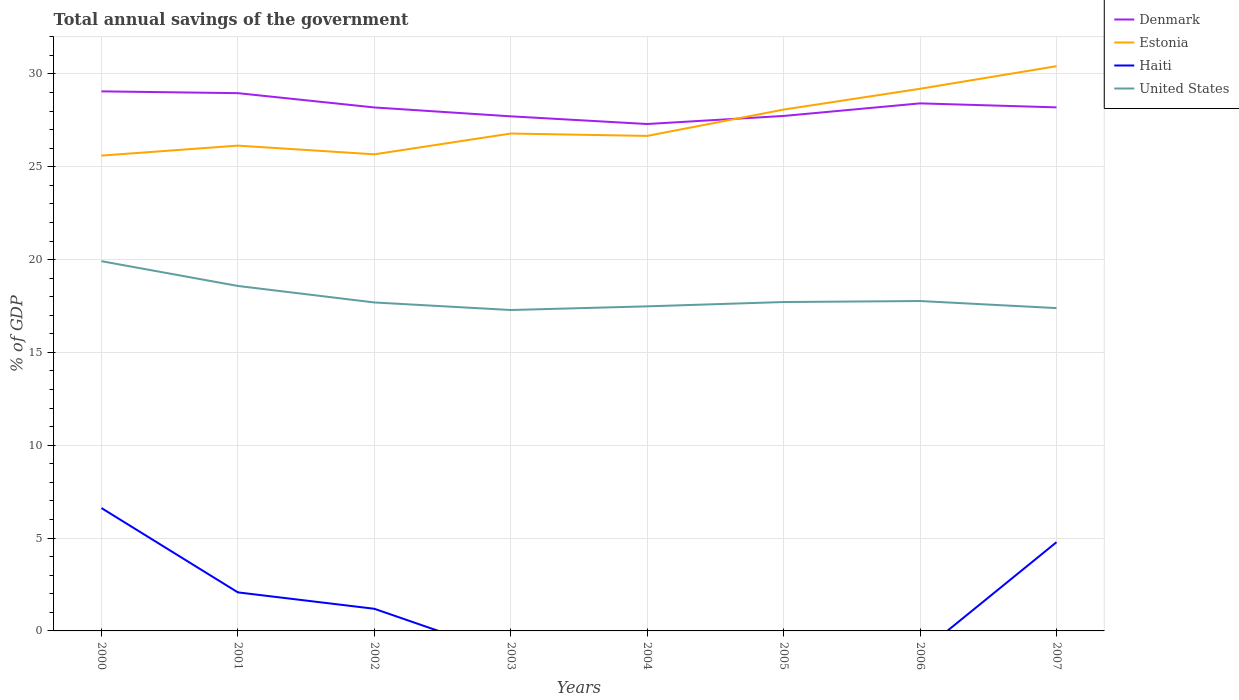How many different coloured lines are there?
Ensure brevity in your answer.  4. Across all years, what is the maximum total annual savings of the government in Estonia?
Keep it short and to the point. 25.6. What is the total total annual savings of the government in Denmark in the graph?
Make the answer very short. 0.1. What is the difference between the highest and the second highest total annual savings of the government in Denmark?
Ensure brevity in your answer.  1.76. What is the difference between the highest and the lowest total annual savings of the government in Haiti?
Provide a short and direct response. 3. How many years are there in the graph?
Your answer should be very brief. 8. What is the difference between two consecutive major ticks on the Y-axis?
Offer a very short reply. 5. Are the values on the major ticks of Y-axis written in scientific E-notation?
Offer a very short reply. No. Where does the legend appear in the graph?
Offer a very short reply. Top right. How many legend labels are there?
Ensure brevity in your answer.  4. What is the title of the graph?
Provide a succinct answer. Total annual savings of the government. Does "Suriname" appear as one of the legend labels in the graph?
Ensure brevity in your answer.  No. What is the label or title of the Y-axis?
Your response must be concise. % of GDP. What is the % of GDP of Denmark in 2000?
Offer a terse response. 29.06. What is the % of GDP of Estonia in 2000?
Keep it short and to the point. 25.6. What is the % of GDP in Haiti in 2000?
Offer a very short reply. 6.62. What is the % of GDP in United States in 2000?
Your response must be concise. 19.92. What is the % of GDP of Denmark in 2001?
Provide a short and direct response. 28.97. What is the % of GDP in Estonia in 2001?
Your answer should be very brief. 26.14. What is the % of GDP of Haiti in 2001?
Ensure brevity in your answer.  2.08. What is the % of GDP of United States in 2001?
Ensure brevity in your answer.  18.58. What is the % of GDP of Denmark in 2002?
Keep it short and to the point. 28.2. What is the % of GDP in Estonia in 2002?
Offer a terse response. 25.67. What is the % of GDP of Haiti in 2002?
Your response must be concise. 1.19. What is the % of GDP in United States in 2002?
Keep it short and to the point. 17.69. What is the % of GDP of Denmark in 2003?
Make the answer very short. 27.72. What is the % of GDP of Estonia in 2003?
Ensure brevity in your answer.  26.79. What is the % of GDP in United States in 2003?
Give a very brief answer. 17.28. What is the % of GDP in Denmark in 2004?
Offer a very short reply. 27.3. What is the % of GDP of Estonia in 2004?
Provide a succinct answer. 26.66. What is the % of GDP of Haiti in 2004?
Give a very brief answer. 0. What is the % of GDP of United States in 2004?
Offer a terse response. 17.48. What is the % of GDP of Denmark in 2005?
Make the answer very short. 27.74. What is the % of GDP of Estonia in 2005?
Your response must be concise. 28.08. What is the % of GDP of United States in 2005?
Provide a short and direct response. 17.72. What is the % of GDP in Denmark in 2006?
Your answer should be very brief. 28.42. What is the % of GDP of Estonia in 2006?
Offer a terse response. 29.2. What is the % of GDP in Haiti in 2006?
Provide a succinct answer. 0. What is the % of GDP of United States in 2006?
Your response must be concise. 17.77. What is the % of GDP of Denmark in 2007?
Provide a short and direct response. 28.2. What is the % of GDP in Estonia in 2007?
Offer a terse response. 30.42. What is the % of GDP of Haiti in 2007?
Provide a short and direct response. 4.78. What is the % of GDP of United States in 2007?
Ensure brevity in your answer.  17.39. Across all years, what is the maximum % of GDP in Denmark?
Your response must be concise. 29.06. Across all years, what is the maximum % of GDP in Estonia?
Offer a terse response. 30.42. Across all years, what is the maximum % of GDP of Haiti?
Provide a succinct answer. 6.62. Across all years, what is the maximum % of GDP in United States?
Keep it short and to the point. 19.92. Across all years, what is the minimum % of GDP of Denmark?
Offer a terse response. 27.3. Across all years, what is the minimum % of GDP in Estonia?
Ensure brevity in your answer.  25.6. Across all years, what is the minimum % of GDP of Haiti?
Provide a short and direct response. 0. Across all years, what is the minimum % of GDP in United States?
Make the answer very short. 17.28. What is the total % of GDP in Denmark in the graph?
Ensure brevity in your answer.  225.6. What is the total % of GDP in Estonia in the graph?
Provide a succinct answer. 218.57. What is the total % of GDP in Haiti in the graph?
Your response must be concise. 14.67. What is the total % of GDP in United States in the graph?
Offer a very short reply. 143.83. What is the difference between the % of GDP in Denmark in 2000 and that in 2001?
Give a very brief answer. 0.1. What is the difference between the % of GDP of Estonia in 2000 and that in 2001?
Your answer should be very brief. -0.54. What is the difference between the % of GDP in Haiti in 2000 and that in 2001?
Give a very brief answer. 4.54. What is the difference between the % of GDP of United States in 2000 and that in 2001?
Provide a short and direct response. 1.33. What is the difference between the % of GDP of Denmark in 2000 and that in 2002?
Keep it short and to the point. 0.87. What is the difference between the % of GDP in Estonia in 2000 and that in 2002?
Make the answer very short. -0.07. What is the difference between the % of GDP of Haiti in 2000 and that in 2002?
Provide a short and direct response. 5.42. What is the difference between the % of GDP in United States in 2000 and that in 2002?
Ensure brevity in your answer.  2.22. What is the difference between the % of GDP in Denmark in 2000 and that in 2003?
Your answer should be compact. 1.35. What is the difference between the % of GDP of Estonia in 2000 and that in 2003?
Provide a short and direct response. -1.19. What is the difference between the % of GDP of United States in 2000 and that in 2003?
Offer a very short reply. 2.63. What is the difference between the % of GDP of Denmark in 2000 and that in 2004?
Your response must be concise. 1.76. What is the difference between the % of GDP of Estonia in 2000 and that in 2004?
Your answer should be very brief. -1.06. What is the difference between the % of GDP of United States in 2000 and that in 2004?
Your answer should be very brief. 2.43. What is the difference between the % of GDP in Denmark in 2000 and that in 2005?
Your answer should be very brief. 1.32. What is the difference between the % of GDP of Estonia in 2000 and that in 2005?
Your answer should be very brief. -2.48. What is the difference between the % of GDP of United States in 2000 and that in 2005?
Ensure brevity in your answer.  2.2. What is the difference between the % of GDP in Denmark in 2000 and that in 2006?
Keep it short and to the point. 0.65. What is the difference between the % of GDP in Estonia in 2000 and that in 2006?
Make the answer very short. -3.6. What is the difference between the % of GDP of United States in 2000 and that in 2006?
Your answer should be very brief. 2.15. What is the difference between the % of GDP of Denmark in 2000 and that in 2007?
Provide a succinct answer. 0.86. What is the difference between the % of GDP of Estonia in 2000 and that in 2007?
Offer a very short reply. -4.82. What is the difference between the % of GDP of Haiti in 2000 and that in 2007?
Provide a succinct answer. 1.84. What is the difference between the % of GDP of United States in 2000 and that in 2007?
Your answer should be very brief. 2.53. What is the difference between the % of GDP of Denmark in 2001 and that in 2002?
Ensure brevity in your answer.  0.77. What is the difference between the % of GDP of Estonia in 2001 and that in 2002?
Keep it short and to the point. 0.47. What is the difference between the % of GDP in Haiti in 2001 and that in 2002?
Give a very brief answer. 0.88. What is the difference between the % of GDP of United States in 2001 and that in 2002?
Give a very brief answer. 0.89. What is the difference between the % of GDP in Denmark in 2001 and that in 2003?
Give a very brief answer. 1.25. What is the difference between the % of GDP in Estonia in 2001 and that in 2003?
Keep it short and to the point. -0.65. What is the difference between the % of GDP in United States in 2001 and that in 2003?
Give a very brief answer. 1.3. What is the difference between the % of GDP in Denmark in 2001 and that in 2004?
Offer a very short reply. 1.66. What is the difference between the % of GDP of Estonia in 2001 and that in 2004?
Ensure brevity in your answer.  -0.52. What is the difference between the % of GDP in United States in 2001 and that in 2004?
Offer a terse response. 1.1. What is the difference between the % of GDP of Denmark in 2001 and that in 2005?
Your response must be concise. 1.23. What is the difference between the % of GDP in Estonia in 2001 and that in 2005?
Your answer should be very brief. -1.94. What is the difference between the % of GDP of United States in 2001 and that in 2005?
Make the answer very short. 0.87. What is the difference between the % of GDP in Denmark in 2001 and that in 2006?
Offer a very short reply. 0.55. What is the difference between the % of GDP of Estonia in 2001 and that in 2006?
Give a very brief answer. -3.06. What is the difference between the % of GDP of United States in 2001 and that in 2006?
Offer a terse response. 0.81. What is the difference between the % of GDP of Denmark in 2001 and that in 2007?
Provide a succinct answer. 0.77. What is the difference between the % of GDP of Estonia in 2001 and that in 2007?
Ensure brevity in your answer.  -4.28. What is the difference between the % of GDP in Haiti in 2001 and that in 2007?
Provide a short and direct response. -2.7. What is the difference between the % of GDP in United States in 2001 and that in 2007?
Make the answer very short. 1.19. What is the difference between the % of GDP of Denmark in 2002 and that in 2003?
Provide a succinct answer. 0.48. What is the difference between the % of GDP of Estonia in 2002 and that in 2003?
Your answer should be compact. -1.12. What is the difference between the % of GDP in United States in 2002 and that in 2003?
Your response must be concise. 0.41. What is the difference between the % of GDP in Denmark in 2002 and that in 2004?
Provide a succinct answer. 0.89. What is the difference between the % of GDP of Estonia in 2002 and that in 2004?
Offer a very short reply. -0.99. What is the difference between the % of GDP in United States in 2002 and that in 2004?
Ensure brevity in your answer.  0.21. What is the difference between the % of GDP of Denmark in 2002 and that in 2005?
Provide a short and direct response. 0.46. What is the difference between the % of GDP in Estonia in 2002 and that in 2005?
Make the answer very short. -2.41. What is the difference between the % of GDP of United States in 2002 and that in 2005?
Your response must be concise. -0.02. What is the difference between the % of GDP in Denmark in 2002 and that in 2006?
Give a very brief answer. -0.22. What is the difference between the % of GDP in Estonia in 2002 and that in 2006?
Provide a short and direct response. -3.53. What is the difference between the % of GDP of United States in 2002 and that in 2006?
Your answer should be very brief. -0.08. What is the difference between the % of GDP of Denmark in 2002 and that in 2007?
Your answer should be very brief. -0.01. What is the difference between the % of GDP in Estonia in 2002 and that in 2007?
Make the answer very short. -4.75. What is the difference between the % of GDP in Haiti in 2002 and that in 2007?
Make the answer very short. -3.59. What is the difference between the % of GDP of United States in 2002 and that in 2007?
Make the answer very short. 0.3. What is the difference between the % of GDP in Denmark in 2003 and that in 2004?
Provide a succinct answer. 0.41. What is the difference between the % of GDP of Estonia in 2003 and that in 2004?
Provide a succinct answer. 0.13. What is the difference between the % of GDP of United States in 2003 and that in 2004?
Provide a short and direct response. -0.2. What is the difference between the % of GDP in Denmark in 2003 and that in 2005?
Offer a very short reply. -0.02. What is the difference between the % of GDP of Estonia in 2003 and that in 2005?
Ensure brevity in your answer.  -1.29. What is the difference between the % of GDP of United States in 2003 and that in 2005?
Offer a terse response. -0.43. What is the difference between the % of GDP of Denmark in 2003 and that in 2006?
Your answer should be very brief. -0.7. What is the difference between the % of GDP of Estonia in 2003 and that in 2006?
Provide a succinct answer. -2.41. What is the difference between the % of GDP of United States in 2003 and that in 2006?
Your answer should be very brief. -0.48. What is the difference between the % of GDP of Denmark in 2003 and that in 2007?
Provide a succinct answer. -0.48. What is the difference between the % of GDP of Estonia in 2003 and that in 2007?
Provide a succinct answer. -3.63. What is the difference between the % of GDP of United States in 2003 and that in 2007?
Keep it short and to the point. -0.1. What is the difference between the % of GDP of Denmark in 2004 and that in 2005?
Offer a terse response. -0.44. What is the difference between the % of GDP of Estonia in 2004 and that in 2005?
Your answer should be compact. -1.42. What is the difference between the % of GDP in United States in 2004 and that in 2005?
Provide a succinct answer. -0.23. What is the difference between the % of GDP of Denmark in 2004 and that in 2006?
Your answer should be very brief. -1.11. What is the difference between the % of GDP in Estonia in 2004 and that in 2006?
Give a very brief answer. -2.54. What is the difference between the % of GDP of United States in 2004 and that in 2006?
Your response must be concise. -0.29. What is the difference between the % of GDP of Denmark in 2004 and that in 2007?
Your answer should be compact. -0.9. What is the difference between the % of GDP in Estonia in 2004 and that in 2007?
Offer a very short reply. -3.75. What is the difference between the % of GDP of United States in 2004 and that in 2007?
Offer a very short reply. 0.09. What is the difference between the % of GDP in Denmark in 2005 and that in 2006?
Provide a succinct answer. -0.68. What is the difference between the % of GDP in Estonia in 2005 and that in 2006?
Ensure brevity in your answer.  -1.12. What is the difference between the % of GDP of United States in 2005 and that in 2006?
Your answer should be very brief. -0.05. What is the difference between the % of GDP in Denmark in 2005 and that in 2007?
Make the answer very short. -0.46. What is the difference between the % of GDP in Estonia in 2005 and that in 2007?
Offer a very short reply. -2.34. What is the difference between the % of GDP of United States in 2005 and that in 2007?
Your answer should be very brief. 0.33. What is the difference between the % of GDP of Denmark in 2006 and that in 2007?
Provide a succinct answer. 0.22. What is the difference between the % of GDP in Estonia in 2006 and that in 2007?
Offer a very short reply. -1.22. What is the difference between the % of GDP of United States in 2006 and that in 2007?
Provide a short and direct response. 0.38. What is the difference between the % of GDP in Denmark in 2000 and the % of GDP in Estonia in 2001?
Keep it short and to the point. 2.92. What is the difference between the % of GDP of Denmark in 2000 and the % of GDP of Haiti in 2001?
Your answer should be compact. 26.99. What is the difference between the % of GDP of Denmark in 2000 and the % of GDP of United States in 2001?
Your answer should be compact. 10.48. What is the difference between the % of GDP in Estonia in 2000 and the % of GDP in Haiti in 2001?
Ensure brevity in your answer.  23.53. What is the difference between the % of GDP of Estonia in 2000 and the % of GDP of United States in 2001?
Your answer should be compact. 7.02. What is the difference between the % of GDP of Haiti in 2000 and the % of GDP of United States in 2001?
Offer a very short reply. -11.96. What is the difference between the % of GDP of Denmark in 2000 and the % of GDP of Estonia in 2002?
Ensure brevity in your answer.  3.39. What is the difference between the % of GDP in Denmark in 2000 and the % of GDP in Haiti in 2002?
Provide a short and direct response. 27.87. What is the difference between the % of GDP in Denmark in 2000 and the % of GDP in United States in 2002?
Make the answer very short. 11.37. What is the difference between the % of GDP in Estonia in 2000 and the % of GDP in Haiti in 2002?
Your answer should be very brief. 24.41. What is the difference between the % of GDP of Estonia in 2000 and the % of GDP of United States in 2002?
Ensure brevity in your answer.  7.91. What is the difference between the % of GDP of Haiti in 2000 and the % of GDP of United States in 2002?
Your answer should be compact. -11.07. What is the difference between the % of GDP of Denmark in 2000 and the % of GDP of Estonia in 2003?
Your answer should be compact. 2.27. What is the difference between the % of GDP in Denmark in 2000 and the % of GDP in United States in 2003?
Ensure brevity in your answer.  11.78. What is the difference between the % of GDP in Estonia in 2000 and the % of GDP in United States in 2003?
Ensure brevity in your answer.  8.32. What is the difference between the % of GDP in Haiti in 2000 and the % of GDP in United States in 2003?
Offer a terse response. -10.67. What is the difference between the % of GDP in Denmark in 2000 and the % of GDP in Estonia in 2004?
Offer a very short reply. 2.4. What is the difference between the % of GDP of Denmark in 2000 and the % of GDP of United States in 2004?
Your answer should be compact. 11.58. What is the difference between the % of GDP in Estonia in 2000 and the % of GDP in United States in 2004?
Your response must be concise. 8.12. What is the difference between the % of GDP in Haiti in 2000 and the % of GDP in United States in 2004?
Provide a succinct answer. -10.86. What is the difference between the % of GDP of Denmark in 2000 and the % of GDP of Estonia in 2005?
Your answer should be compact. 0.98. What is the difference between the % of GDP of Denmark in 2000 and the % of GDP of United States in 2005?
Keep it short and to the point. 11.35. What is the difference between the % of GDP of Estonia in 2000 and the % of GDP of United States in 2005?
Your answer should be very brief. 7.89. What is the difference between the % of GDP of Haiti in 2000 and the % of GDP of United States in 2005?
Give a very brief answer. -11.1. What is the difference between the % of GDP of Denmark in 2000 and the % of GDP of Estonia in 2006?
Your answer should be compact. -0.14. What is the difference between the % of GDP in Denmark in 2000 and the % of GDP in United States in 2006?
Provide a short and direct response. 11.29. What is the difference between the % of GDP of Estonia in 2000 and the % of GDP of United States in 2006?
Your response must be concise. 7.83. What is the difference between the % of GDP of Haiti in 2000 and the % of GDP of United States in 2006?
Your answer should be compact. -11.15. What is the difference between the % of GDP of Denmark in 2000 and the % of GDP of Estonia in 2007?
Your answer should be very brief. -1.36. What is the difference between the % of GDP in Denmark in 2000 and the % of GDP in Haiti in 2007?
Keep it short and to the point. 24.28. What is the difference between the % of GDP in Denmark in 2000 and the % of GDP in United States in 2007?
Keep it short and to the point. 11.67. What is the difference between the % of GDP of Estonia in 2000 and the % of GDP of Haiti in 2007?
Your answer should be compact. 20.82. What is the difference between the % of GDP in Estonia in 2000 and the % of GDP in United States in 2007?
Offer a terse response. 8.21. What is the difference between the % of GDP of Haiti in 2000 and the % of GDP of United States in 2007?
Provide a short and direct response. -10.77. What is the difference between the % of GDP of Denmark in 2001 and the % of GDP of Estonia in 2002?
Keep it short and to the point. 3.29. What is the difference between the % of GDP of Denmark in 2001 and the % of GDP of Haiti in 2002?
Provide a succinct answer. 27.77. What is the difference between the % of GDP of Denmark in 2001 and the % of GDP of United States in 2002?
Provide a short and direct response. 11.27. What is the difference between the % of GDP in Estonia in 2001 and the % of GDP in Haiti in 2002?
Offer a terse response. 24.95. What is the difference between the % of GDP in Estonia in 2001 and the % of GDP in United States in 2002?
Give a very brief answer. 8.45. What is the difference between the % of GDP in Haiti in 2001 and the % of GDP in United States in 2002?
Ensure brevity in your answer.  -15.62. What is the difference between the % of GDP in Denmark in 2001 and the % of GDP in Estonia in 2003?
Provide a short and direct response. 2.17. What is the difference between the % of GDP in Denmark in 2001 and the % of GDP in United States in 2003?
Provide a succinct answer. 11.68. What is the difference between the % of GDP in Estonia in 2001 and the % of GDP in United States in 2003?
Provide a short and direct response. 8.86. What is the difference between the % of GDP in Haiti in 2001 and the % of GDP in United States in 2003?
Provide a short and direct response. -15.21. What is the difference between the % of GDP of Denmark in 2001 and the % of GDP of Estonia in 2004?
Ensure brevity in your answer.  2.3. What is the difference between the % of GDP in Denmark in 2001 and the % of GDP in United States in 2004?
Ensure brevity in your answer.  11.48. What is the difference between the % of GDP in Estonia in 2001 and the % of GDP in United States in 2004?
Your response must be concise. 8.66. What is the difference between the % of GDP in Haiti in 2001 and the % of GDP in United States in 2004?
Provide a succinct answer. -15.41. What is the difference between the % of GDP of Denmark in 2001 and the % of GDP of Estonia in 2005?
Your answer should be very brief. 0.89. What is the difference between the % of GDP of Denmark in 2001 and the % of GDP of United States in 2005?
Offer a very short reply. 11.25. What is the difference between the % of GDP of Estonia in 2001 and the % of GDP of United States in 2005?
Your answer should be compact. 8.42. What is the difference between the % of GDP of Haiti in 2001 and the % of GDP of United States in 2005?
Provide a short and direct response. -15.64. What is the difference between the % of GDP of Denmark in 2001 and the % of GDP of Estonia in 2006?
Your answer should be very brief. -0.24. What is the difference between the % of GDP of Denmark in 2001 and the % of GDP of United States in 2006?
Your answer should be very brief. 11.2. What is the difference between the % of GDP of Estonia in 2001 and the % of GDP of United States in 2006?
Your answer should be very brief. 8.37. What is the difference between the % of GDP of Haiti in 2001 and the % of GDP of United States in 2006?
Offer a very short reply. -15.69. What is the difference between the % of GDP of Denmark in 2001 and the % of GDP of Estonia in 2007?
Your response must be concise. -1.45. What is the difference between the % of GDP of Denmark in 2001 and the % of GDP of Haiti in 2007?
Make the answer very short. 24.19. What is the difference between the % of GDP in Denmark in 2001 and the % of GDP in United States in 2007?
Ensure brevity in your answer.  11.58. What is the difference between the % of GDP of Estonia in 2001 and the % of GDP of Haiti in 2007?
Ensure brevity in your answer.  21.36. What is the difference between the % of GDP in Estonia in 2001 and the % of GDP in United States in 2007?
Make the answer very short. 8.75. What is the difference between the % of GDP in Haiti in 2001 and the % of GDP in United States in 2007?
Your answer should be very brief. -15.31. What is the difference between the % of GDP in Denmark in 2002 and the % of GDP in Estonia in 2003?
Your answer should be compact. 1.4. What is the difference between the % of GDP in Denmark in 2002 and the % of GDP in United States in 2003?
Offer a very short reply. 10.91. What is the difference between the % of GDP in Estonia in 2002 and the % of GDP in United States in 2003?
Your answer should be compact. 8.39. What is the difference between the % of GDP in Haiti in 2002 and the % of GDP in United States in 2003?
Provide a succinct answer. -16.09. What is the difference between the % of GDP of Denmark in 2002 and the % of GDP of Estonia in 2004?
Provide a short and direct response. 1.53. What is the difference between the % of GDP of Denmark in 2002 and the % of GDP of United States in 2004?
Offer a terse response. 10.71. What is the difference between the % of GDP in Estonia in 2002 and the % of GDP in United States in 2004?
Provide a short and direct response. 8.19. What is the difference between the % of GDP in Haiti in 2002 and the % of GDP in United States in 2004?
Keep it short and to the point. -16.29. What is the difference between the % of GDP in Denmark in 2002 and the % of GDP in Estonia in 2005?
Ensure brevity in your answer.  0.12. What is the difference between the % of GDP in Denmark in 2002 and the % of GDP in United States in 2005?
Ensure brevity in your answer.  10.48. What is the difference between the % of GDP in Estonia in 2002 and the % of GDP in United States in 2005?
Provide a succinct answer. 7.96. What is the difference between the % of GDP in Haiti in 2002 and the % of GDP in United States in 2005?
Offer a very short reply. -16.52. What is the difference between the % of GDP in Denmark in 2002 and the % of GDP in Estonia in 2006?
Your answer should be compact. -1.01. What is the difference between the % of GDP in Denmark in 2002 and the % of GDP in United States in 2006?
Offer a terse response. 10.43. What is the difference between the % of GDP of Estonia in 2002 and the % of GDP of United States in 2006?
Your answer should be compact. 7.9. What is the difference between the % of GDP of Haiti in 2002 and the % of GDP of United States in 2006?
Give a very brief answer. -16.58. What is the difference between the % of GDP in Denmark in 2002 and the % of GDP in Estonia in 2007?
Give a very brief answer. -2.22. What is the difference between the % of GDP of Denmark in 2002 and the % of GDP of Haiti in 2007?
Your answer should be very brief. 23.42. What is the difference between the % of GDP of Denmark in 2002 and the % of GDP of United States in 2007?
Your answer should be compact. 10.81. What is the difference between the % of GDP in Estonia in 2002 and the % of GDP in Haiti in 2007?
Provide a succinct answer. 20.89. What is the difference between the % of GDP of Estonia in 2002 and the % of GDP of United States in 2007?
Your answer should be very brief. 8.28. What is the difference between the % of GDP of Haiti in 2002 and the % of GDP of United States in 2007?
Your answer should be compact. -16.2. What is the difference between the % of GDP in Denmark in 2003 and the % of GDP in Estonia in 2004?
Offer a very short reply. 1.05. What is the difference between the % of GDP of Denmark in 2003 and the % of GDP of United States in 2004?
Your answer should be very brief. 10.23. What is the difference between the % of GDP in Estonia in 2003 and the % of GDP in United States in 2004?
Ensure brevity in your answer.  9.31. What is the difference between the % of GDP in Denmark in 2003 and the % of GDP in Estonia in 2005?
Keep it short and to the point. -0.36. What is the difference between the % of GDP of Denmark in 2003 and the % of GDP of United States in 2005?
Offer a terse response. 10. What is the difference between the % of GDP in Estonia in 2003 and the % of GDP in United States in 2005?
Keep it short and to the point. 9.08. What is the difference between the % of GDP in Denmark in 2003 and the % of GDP in Estonia in 2006?
Ensure brevity in your answer.  -1.49. What is the difference between the % of GDP of Denmark in 2003 and the % of GDP of United States in 2006?
Give a very brief answer. 9.95. What is the difference between the % of GDP of Estonia in 2003 and the % of GDP of United States in 2006?
Ensure brevity in your answer.  9.02. What is the difference between the % of GDP of Denmark in 2003 and the % of GDP of Estonia in 2007?
Your response must be concise. -2.7. What is the difference between the % of GDP in Denmark in 2003 and the % of GDP in Haiti in 2007?
Provide a short and direct response. 22.94. What is the difference between the % of GDP in Denmark in 2003 and the % of GDP in United States in 2007?
Your answer should be compact. 10.33. What is the difference between the % of GDP in Estonia in 2003 and the % of GDP in Haiti in 2007?
Keep it short and to the point. 22.01. What is the difference between the % of GDP in Estonia in 2003 and the % of GDP in United States in 2007?
Keep it short and to the point. 9.4. What is the difference between the % of GDP in Denmark in 2004 and the % of GDP in Estonia in 2005?
Provide a succinct answer. -0.78. What is the difference between the % of GDP in Denmark in 2004 and the % of GDP in United States in 2005?
Give a very brief answer. 9.59. What is the difference between the % of GDP of Estonia in 2004 and the % of GDP of United States in 2005?
Provide a succinct answer. 8.95. What is the difference between the % of GDP of Denmark in 2004 and the % of GDP of Estonia in 2006?
Keep it short and to the point. -1.9. What is the difference between the % of GDP of Denmark in 2004 and the % of GDP of United States in 2006?
Keep it short and to the point. 9.53. What is the difference between the % of GDP in Estonia in 2004 and the % of GDP in United States in 2006?
Make the answer very short. 8.89. What is the difference between the % of GDP in Denmark in 2004 and the % of GDP in Estonia in 2007?
Keep it short and to the point. -3.12. What is the difference between the % of GDP in Denmark in 2004 and the % of GDP in Haiti in 2007?
Offer a very short reply. 22.52. What is the difference between the % of GDP in Denmark in 2004 and the % of GDP in United States in 2007?
Give a very brief answer. 9.91. What is the difference between the % of GDP in Estonia in 2004 and the % of GDP in Haiti in 2007?
Offer a very short reply. 21.88. What is the difference between the % of GDP of Estonia in 2004 and the % of GDP of United States in 2007?
Your answer should be very brief. 9.27. What is the difference between the % of GDP of Denmark in 2005 and the % of GDP of Estonia in 2006?
Ensure brevity in your answer.  -1.46. What is the difference between the % of GDP of Denmark in 2005 and the % of GDP of United States in 2006?
Your response must be concise. 9.97. What is the difference between the % of GDP of Estonia in 2005 and the % of GDP of United States in 2006?
Provide a short and direct response. 10.31. What is the difference between the % of GDP of Denmark in 2005 and the % of GDP of Estonia in 2007?
Ensure brevity in your answer.  -2.68. What is the difference between the % of GDP of Denmark in 2005 and the % of GDP of Haiti in 2007?
Your response must be concise. 22.96. What is the difference between the % of GDP in Denmark in 2005 and the % of GDP in United States in 2007?
Give a very brief answer. 10.35. What is the difference between the % of GDP in Estonia in 2005 and the % of GDP in Haiti in 2007?
Offer a very short reply. 23.3. What is the difference between the % of GDP in Estonia in 2005 and the % of GDP in United States in 2007?
Provide a succinct answer. 10.69. What is the difference between the % of GDP in Denmark in 2006 and the % of GDP in Estonia in 2007?
Provide a short and direct response. -2. What is the difference between the % of GDP of Denmark in 2006 and the % of GDP of Haiti in 2007?
Keep it short and to the point. 23.64. What is the difference between the % of GDP in Denmark in 2006 and the % of GDP in United States in 2007?
Make the answer very short. 11.03. What is the difference between the % of GDP in Estonia in 2006 and the % of GDP in Haiti in 2007?
Make the answer very short. 24.42. What is the difference between the % of GDP of Estonia in 2006 and the % of GDP of United States in 2007?
Ensure brevity in your answer.  11.81. What is the average % of GDP in Denmark per year?
Offer a terse response. 28.2. What is the average % of GDP in Estonia per year?
Provide a short and direct response. 27.32. What is the average % of GDP in Haiti per year?
Your answer should be very brief. 1.83. What is the average % of GDP in United States per year?
Provide a short and direct response. 17.98. In the year 2000, what is the difference between the % of GDP of Denmark and % of GDP of Estonia?
Give a very brief answer. 3.46. In the year 2000, what is the difference between the % of GDP of Denmark and % of GDP of Haiti?
Provide a succinct answer. 22.44. In the year 2000, what is the difference between the % of GDP in Denmark and % of GDP in United States?
Offer a very short reply. 9.15. In the year 2000, what is the difference between the % of GDP of Estonia and % of GDP of Haiti?
Your response must be concise. 18.98. In the year 2000, what is the difference between the % of GDP in Estonia and % of GDP in United States?
Offer a very short reply. 5.69. In the year 2000, what is the difference between the % of GDP in Haiti and % of GDP in United States?
Provide a succinct answer. -13.3. In the year 2001, what is the difference between the % of GDP of Denmark and % of GDP of Estonia?
Ensure brevity in your answer.  2.83. In the year 2001, what is the difference between the % of GDP of Denmark and % of GDP of Haiti?
Your answer should be compact. 26.89. In the year 2001, what is the difference between the % of GDP of Denmark and % of GDP of United States?
Your answer should be compact. 10.39. In the year 2001, what is the difference between the % of GDP in Estonia and % of GDP in Haiti?
Your answer should be compact. 24.06. In the year 2001, what is the difference between the % of GDP in Estonia and % of GDP in United States?
Keep it short and to the point. 7.56. In the year 2001, what is the difference between the % of GDP of Haiti and % of GDP of United States?
Provide a succinct answer. -16.5. In the year 2002, what is the difference between the % of GDP of Denmark and % of GDP of Estonia?
Your answer should be very brief. 2.52. In the year 2002, what is the difference between the % of GDP of Denmark and % of GDP of Haiti?
Your answer should be very brief. 27. In the year 2002, what is the difference between the % of GDP in Denmark and % of GDP in United States?
Keep it short and to the point. 10.5. In the year 2002, what is the difference between the % of GDP of Estonia and % of GDP of Haiti?
Make the answer very short. 24.48. In the year 2002, what is the difference between the % of GDP of Estonia and % of GDP of United States?
Give a very brief answer. 7.98. In the year 2002, what is the difference between the % of GDP in Haiti and % of GDP in United States?
Ensure brevity in your answer.  -16.5. In the year 2003, what is the difference between the % of GDP in Denmark and % of GDP in Estonia?
Provide a short and direct response. 0.93. In the year 2003, what is the difference between the % of GDP in Denmark and % of GDP in United States?
Make the answer very short. 10.43. In the year 2003, what is the difference between the % of GDP of Estonia and % of GDP of United States?
Give a very brief answer. 9.51. In the year 2004, what is the difference between the % of GDP in Denmark and % of GDP in Estonia?
Your answer should be compact. 0.64. In the year 2004, what is the difference between the % of GDP of Denmark and % of GDP of United States?
Offer a terse response. 9.82. In the year 2004, what is the difference between the % of GDP of Estonia and % of GDP of United States?
Offer a very short reply. 9.18. In the year 2005, what is the difference between the % of GDP in Denmark and % of GDP in Estonia?
Provide a succinct answer. -0.34. In the year 2005, what is the difference between the % of GDP in Denmark and % of GDP in United States?
Ensure brevity in your answer.  10.02. In the year 2005, what is the difference between the % of GDP in Estonia and % of GDP in United States?
Ensure brevity in your answer.  10.36. In the year 2006, what is the difference between the % of GDP in Denmark and % of GDP in Estonia?
Give a very brief answer. -0.79. In the year 2006, what is the difference between the % of GDP of Denmark and % of GDP of United States?
Keep it short and to the point. 10.65. In the year 2006, what is the difference between the % of GDP in Estonia and % of GDP in United States?
Offer a very short reply. 11.43. In the year 2007, what is the difference between the % of GDP in Denmark and % of GDP in Estonia?
Your answer should be compact. -2.22. In the year 2007, what is the difference between the % of GDP in Denmark and % of GDP in Haiti?
Offer a terse response. 23.42. In the year 2007, what is the difference between the % of GDP in Denmark and % of GDP in United States?
Your answer should be very brief. 10.81. In the year 2007, what is the difference between the % of GDP in Estonia and % of GDP in Haiti?
Offer a very short reply. 25.64. In the year 2007, what is the difference between the % of GDP of Estonia and % of GDP of United States?
Offer a terse response. 13.03. In the year 2007, what is the difference between the % of GDP of Haiti and % of GDP of United States?
Give a very brief answer. -12.61. What is the ratio of the % of GDP of Estonia in 2000 to that in 2001?
Your answer should be compact. 0.98. What is the ratio of the % of GDP of Haiti in 2000 to that in 2001?
Your response must be concise. 3.19. What is the ratio of the % of GDP of United States in 2000 to that in 2001?
Offer a terse response. 1.07. What is the ratio of the % of GDP in Denmark in 2000 to that in 2002?
Provide a short and direct response. 1.03. What is the ratio of the % of GDP of Haiti in 2000 to that in 2002?
Ensure brevity in your answer.  5.55. What is the ratio of the % of GDP of United States in 2000 to that in 2002?
Offer a terse response. 1.13. What is the ratio of the % of GDP of Denmark in 2000 to that in 2003?
Keep it short and to the point. 1.05. What is the ratio of the % of GDP of Estonia in 2000 to that in 2003?
Your answer should be compact. 0.96. What is the ratio of the % of GDP of United States in 2000 to that in 2003?
Provide a succinct answer. 1.15. What is the ratio of the % of GDP in Denmark in 2000 to that in 2004?
Your answer should be compact. 1.06. What is the ratio of the % of GDP of Estonia in 2000 to that in 2004?
Ensure brevity in your answer.  0.96. What is the ratio of the % of GDP in United States in 2000 to that in 2004?
Your response must be concise. 1.14. What is the ratio of the % of GDP in Denmark in 2000 to that in 2005?
Offer a terse response. 1.05. What is the ratio of the % of GDP of Estonia in 2000 to that in 2005?
Give a very brief answer. 0.91. What is the ratio of the % of GDP in United States in 2000 to that in 2005?
Your response must be concise. 1.12. What is the ratio of the % of GDP of Denmark in 2000 to that in 2006?
Provide a succinct answer. 1.02. What is the ratio of the % of GDP in Estonia in 2000 to that in 2006?
Offer a terse response. 0.88. What is the ratio of the % of GDP of United States in 2000 to that in 2006?
Provide a short and direct response. 1.12. What is the ratio of the % of GDP in Denmark in 2000 to that in 2007?
Make the answer very short. 1.03. What is the ratio of the % of GDP in Estonia in 2000 to that in 2007?
Your answer should be very brief. 0.84. What is the ratio of the % of GDP in Haiti in 2000 to that in 2007?
Offer a terse response. 1.38. What is the ratio of the % of GDP of United States in 2000 to that in 2007?
Ensure brevity in your answer.  1.15. What is the ratio of the % of GDP in Denmark in 2001 to that in 2002?
Ensure brevity in your answer.  1.03. What is the ratio of the % of GDP in Estonia in 2001 to that in 2002?
Keep it short and to the point. 1.02. What is the ratio of the % of GDP in Haiti in 2001 to that in 2002?
Offer a very short reply. 1.74. What is the ratio of the % of GDP in United States in 2001 to that in 2002?
Your answer should be very brief. 1.05. What is the ratio of the % of GDP in Denmark in 2001 to that in 2003?
Your answer should be very brief. 1.05. What is the ratio of the % of GDP of Estonia in 2001 to that in 2003?
Ensure brevity in your answer.  0.98. What is the ratio of the % of GDP of United States in 2001 to that in 2003?
Keep it short and to the point. 1.07. What is the ratio of the % of GDP in Denmark in 2001 to that in 2004?
Provide a succinct answer. 1.06. What is the ratio of the % of GDP of Estonia in 2001 to that in 2004?
Make the answer very short. 0.98. What is the ratio of the % of GDP of United States in 2001 to that in 2004?
Keep it short and to the point. 1.06. What is the ratio of the % of GDP of Denmark in 2001 to that in 2005?
Ensure brevity in your answer.  1.04. What is the ratio of the % of GDP of Estonia in 2001 to that in 2005?
Keep it short and to the point. 0.93. What is the ratio of the % of GDP of United States in 2001 to that in 2005?
Make the answer very short. 1.05. What is the ratio of the % of GDP in Denmark in 2001 to that in 2006?
Give a very brief answer. 1.02. What is the ratio of the % of GDP in Estonia in 2001 to that in 2006?
Provide a succinct answer. 0.9. What is the ratio of the % of GDP in United States in 2001 to that in 2006?
Offer a very short reply. 1.05. What is the ratio of the % of GDP in Denmark in 2001 to that in 2007?
Make the answer very short. 1.03. What is the ratio of the % of GDP in Estonia in 2001 to that in 2007?
Offer a terse response. 0.86. What is the ratio of the % of GDP in Haiti in 2001 to that in 2007?
Provide a short and direct response. 0.43. What is the ratio of the % of GDP in United States in 2001 to that in 2007?
Provide a short and direct response. 1.07. What is the ratio of the % of GDP of Denmark in 2002 to that in 2003?
Ensure brevity in your answer.  1.02. What is the ratio of the % of GDP in Estonia in 2002 to that in 2003?
Your answer should be very brief. 0.96. What is the ratio of the % of GDP in United States in 2002 to that in 2003?
Your response must be concise. 1.02. What is the ratio of the % of GDP in Denmark in 2002 to that in 2004?
Your answer should be very brief. 1.03. What is the ratio of the % of GDP of Estonia in 2002 to that in 2004?
Provide a succinct answer. 0.96. What is the ratio of the % of GDP in Denmark in 2002 to that in 2005?
Your answer should be compact. 1.02. What is the ratio of the % of GDP of Estonia in 2002 to that in 2005?
Make the answer very short. 0.91. What is the ratio of the % of GDP of Estonia in 2002 to that in 2006?
Give a very brief answer. 0.88. What is the ratio of the % of GDP of Estonia in 2002 to that in 2007?
Give a very brief answer. 0.84. What is the ratio of the % of GDP in Haiti in 2002 to that in 2007?
Offer a very short reply. 0.25. What is the ratio of the % of GDP of United States in 2002 to that in 2007?
Keep it short and to the point. 1.02. What is the ratio of the % of GDP in Denmark in 2003 to that in 2004?
Ensure brevity in your answer.  1.02. What is the ratio of the % of GDP of United States in 2003 to that in 2004?
Offer a terse response. 0.99. What is the ratio of the % of GDP in Denmark in 2003 to that in 2005?
Ensure brevity in your answer.  1. What is the ratio of the % of GDP in Estonia in 2003 to that in 2005?
Make the answer very short. 0.95. What is the ratio of the % of GDP of United States in 2003 to that in 2005?
Offer a terse response. 0.98. What is the ratio of the % of GDP of Denmark in 2003 to that in 2006?
Your answer should be compact. 0.98. What is the ratio of the % of GDP in Estonia in 2003 to that in 2006?
Offer a very short reply. 0.92. What is the ratio of the % of GDP in United States in 2003 to that in 2006?
Your answer should be compact. 0.97. What is the ratio of the % of GDP of Denmark in 2003 to that in 2007?
Offer a very short reply. 0.98. What is the ratio of the % of GDP in Estonia in 2003 to that in 2007?
Offer a terse response. 0.88. What is the ratio of the % of GDP of Denmark in 2004 to that in 2005?
Your answer should be very brief. 0.98. What is the ratio of the % of GDP of Estonia in 2004 to that in 2005?
Your response must be concise. 0.95. What is the ratio of the % of GDP in United States in 2004 to that in 2005?
Offer a terse response. 0.99. What is the ratio of the % of GDP in Denmark in 2004 to that in 2006?
Offer a terse response. 0.96. What is the ratio of the % of GDP in Estonia in 2004 to that in 2006?
Your answer should be compact. 0.91. What is the ratio of the % of GDP in United States in 2004 to that in 2006?
Provide a succinct answer. 0.98. What is the ratio of the % of GDP of Denmark in 2004 to that in 2007?
Your response must be concise. 0.97. What is the ratio of the % of GDP in Estonia in 2004 to that in 2007?
Keep it short and to the point. 0.88. What is the ratio of the % of GDP in United States in 2004 to that in 2007?
Make the answer very short. 1.01. What is the ratio of the % of GDP in Denmark in 2005 to that in 2006?
Keep it short and to the point. 0.98. What is the ratio of the % of GDP of Estonia in 2005 to that in 2006?
Your response must be concise. 0.96. What is the ratio of the % of GDP in United States in 2005 to that in 2006?
Provide a succinct answer. 1. What is the ratio of the % of GDP in Denmark in 2005 to that in 2007?
Your response must be concise. 0.98. What is the ratio of the % of GDP of Estonia in 2005 to that in 2007?
Offer a terse response. 0.92. What is the ratio of the % of GDP of United States in 2005 to that in 2007?
Your response must be concise. 1.02. What is the ratio of the % of GDP in Denmark in 2006 to that in 2007?
Provide a short and direct response. 1.01. What is the ratio of the % of GDP of United States in 2006 to that in 2007?
Give a very brief answer. 1.02. What is the difference between the highest and the second highest % of GDP of Denmark?
Provide a succinct answer. 0.1. What is the difference between the highest and the second highest % of GDP of Estonia?
Your response must be concise. 1.22. What is the difference between the highest and the second highest % of GDP of Haiti?
Your response must be concise. 1.84. What is the difference between the highest and the second highest % of GDP in United States?
Offer a very short reply. 1.33. What is the difference between the highest and the lowest % of GDP of Denmark?
Make the answer very short. 1.76. What is the difference between the highest and the lowest % of GDP of Estonia?
Give a very brief answer. 4.82. What is the difference between the highest and the lowest % of GDP of Haiti?
Make the answer very short. 6.62. What is the difference between the highest and the lowest % of GDP in United States?
Ensure brevity in your answer.  2.63. 